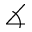Convert formula to latex. <formula><loc_0><loc_0><loc_500><loc_500>\measuredangle</formula> 